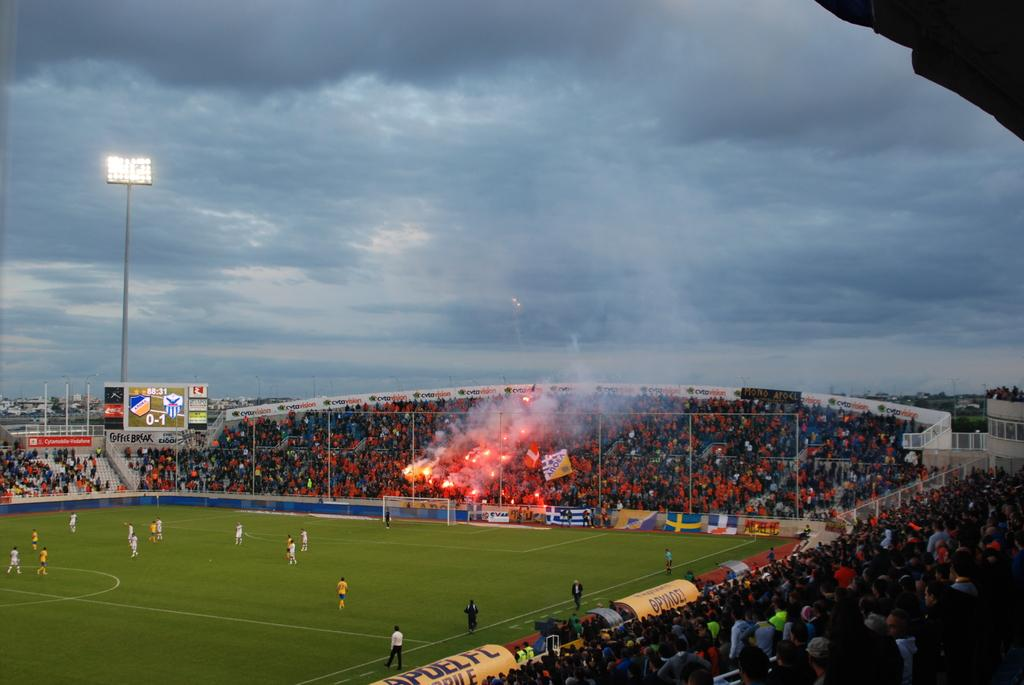<image>
Present a compact description of the photo's key features. a sports stadium with full stands sponsored by Coffee Break 